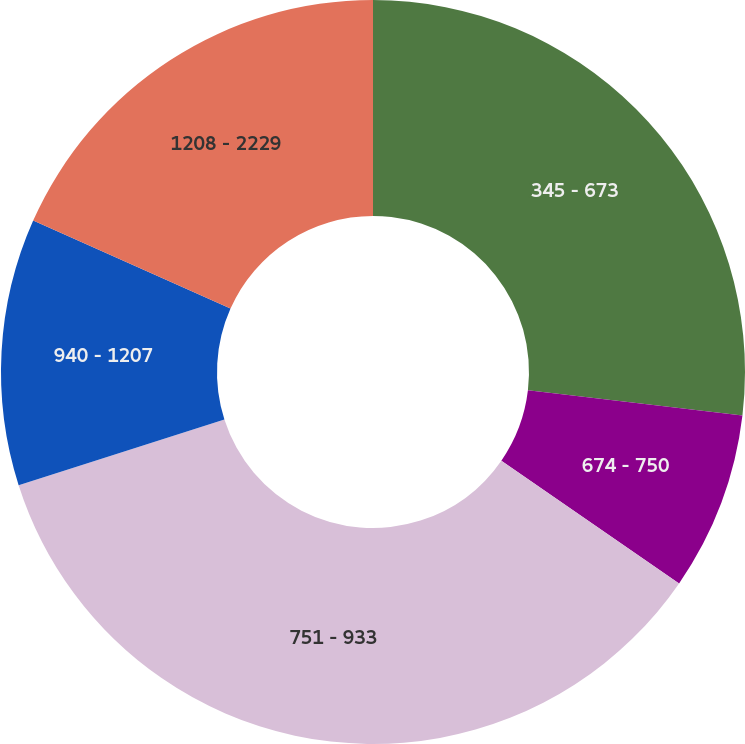Convert chart to OTSL. <chart><loc_0><loc_0><loc_500><loc_500><pie_chart><fcel>345 - 673<fcel>674 - 750<fcel>751 - 933<fcel>940 - 1207<fcel>1208 - 2229<nl><fcel>26.87%<fcel>7.75%<fcel>35.46%<fcel>11.59%<fcel>18.33%<nl></chart> 